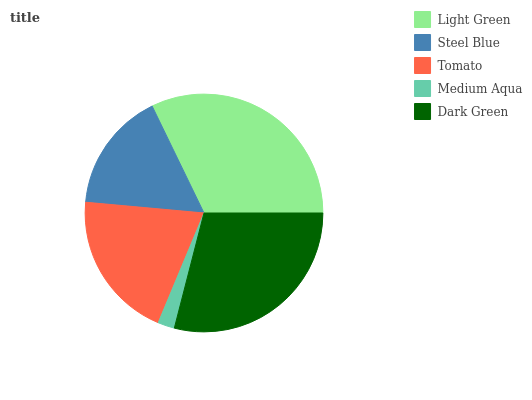Is Medium Aqua the minimum?
Answer yes or no. Yes. Is Light Green the maximum?
Answer yes or no. Yes. Is Steel Blue the minimum?
Answer yes or no. No. Is Steel Blue the maximum?
Answer yes or no. No. Is Light Green greater than Steel Blue?
Answer yes or no. Yes. Is Steel Blue less than Light Green?
Answer yes or no. Yes. Is Steel Blue greater than Light Green?
Answer yes or no. No. Is Light Green less than Steel Blue?
Answer yes or no. No. Is Tomato the high median?
Answer yes or no. Yes. Is Tomato the low median?
Answer yes or no. Yes. Is Dark Green the high median?
Answer yes or no. No. Is Medium Aqua the low median?
Answer yes or no. No. 